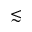<formula> <loc_0><loc_0><loc_500><loc_500>\lesssim</formula> 